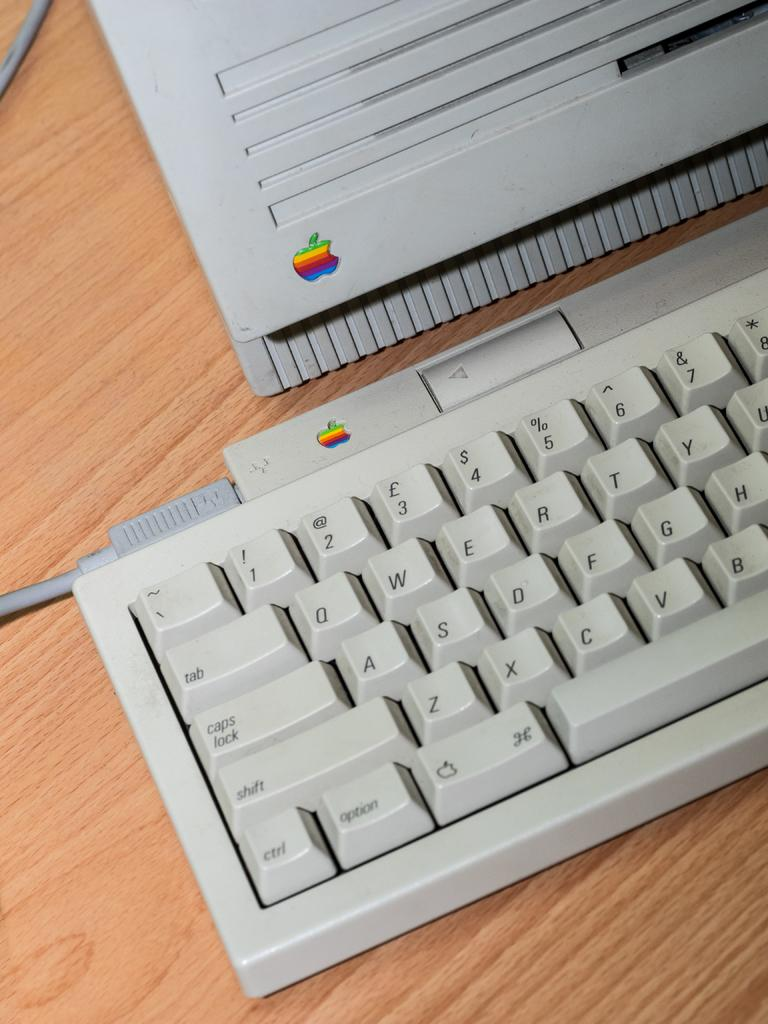Provide a one-sentence caption for the provided image. An old Macintosh computer with the rainbow colored apple emblazoned on it. 